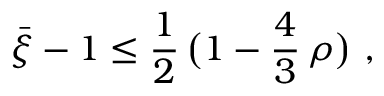<formula> <loc_0><loc_0><loc_500><loc_500>\bar { \xi } - 1 \leq \frac { 1 } { 2 } \, \left ( 1 - \frac { 4 } { 3 } \, \rho \right ) ,</formula> 